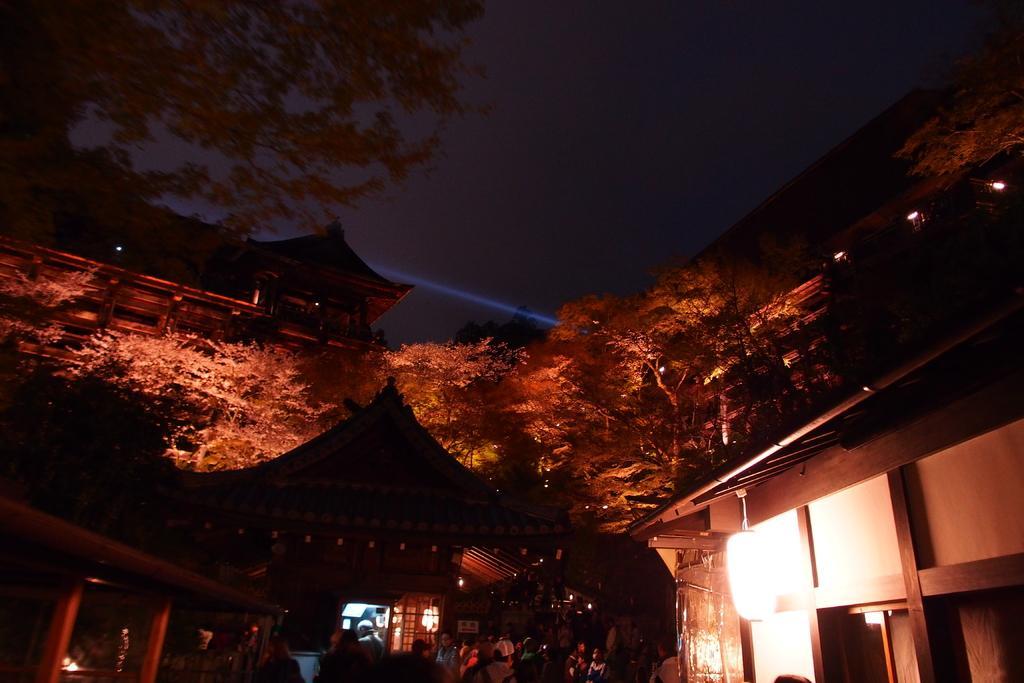Please provide a concise description of this image. In the picture we can see group of persons standing, there are some houses and in the background of the picture there are some trees and dark sky. 